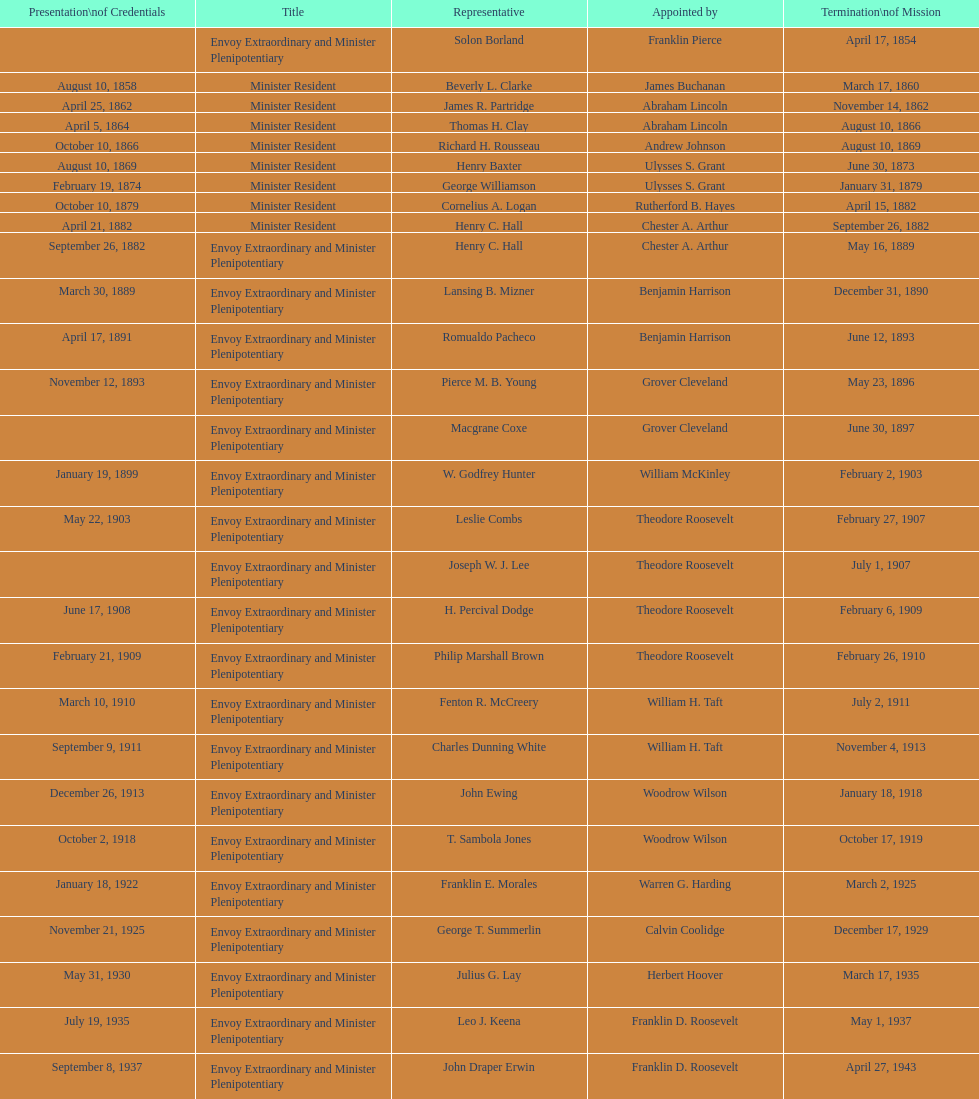Who is the sole ambassador appointed by barack obama to represent the us in honduras? Lisa Kubiske. Help me parse the entirety of this table. {'header': ['Presentation\\nof Credentials', 'Title', 'Representative', 'Appointed by', 'Termination\\nof Mission'], 'rows': [['', 'Envoy Extraordinary and Minister Plenipotentiary', 'Solon Borland', 'Franklin Pierce', 'April 17, 1854'], ['August 10, 1858', 'Minister Resident', 'Beverly L. Clarke', 'James Buchanan', 'March 17, 1860'], ['April 25, 1862', 'Minister Resident', 'James R. Partridge', 'Abraham Lincoln', 'November 14, 1862'], ['April 5, 1864', 'Minister Resident', 'Thomas H. Clay', 'Abraham Lincoln', 'August 10, 1866'], ['October 10, 1866', 'Minister Resident', 'Richard H. Rousseau', 'Andrew Johnson', 'August 10, 1869'], ['August 10, 1869', 'Minister Resident', 'Henry Baxter', 'Ulysses S. Grant', 'June 30, 1873'], ['February 19, 1874', 'Minister Resident', 'George Williamson', 'Ulysses S. Grant', 'January 31, 1879'], ['October 10, 1879', 'Minister Resident', 'Cornelius A. Logan', 'Rutherford B. Hayes', 'April 15, 1882'], ['April 21, 1882', 'Minister Resident', 'Henry C. Hall', 'Chester A. Arthur', 'September 26, 1882'], ['September 26, 1882', 'Envoy Extraordinary and Minister Plenipotentiary', 'Henry C. Hall', 'Chester A. Arthur', 'May 16, 1889'], ['March 30, 1889', 'Envoy Extraordinary and Minister Plenipotentiary', 'Lansing B. Mizner', 'Benjamin Harrison', 'December 31, 1890'], ['April 17, 1891', 'Envoy Extraordinary and Minister Plenipotentiary', 'Romualdo Pacheco', 'Benjamin Harrison', 'June 12, 1893'], ['November 12, 1893', 'Envoy Extraordinary and Minister Plenipotentiary', 'Pierce M. B. Young', 'Grover Cleveland', 'May 23, 1896'], ['', 'Envoy Extraordinary and Minister Plenipotentiary', 'Macgrane Coxe', 'Grover Cleveland', 'June 30, 1897'], ['January 19, 1899', 'Envoy Extraordinary and Minister Plenipotentiary', 'W. Godfrey Hunter', 'William McKinley', 'February 2, 1903'], ['May 22, 1903', 'Envoy Extraordinary and Minister Plenipotentiary', 'Leslie Combs', 'Theodore Roosevelt', 'February 27, 1907'], ['', 'Envoy Extraordinary and Minister Plenipotentiary', 'Joseph W. J. Lee', 'Theodore Roosevelt', 'July 1, 1907'], ['June 17, 1908', 'Envoy Extraordinary and Minister Plenipotentiary', 'H. Percival Dodge', 'Theodore Roosevelt', 'February 6, 1909'], ['February 21, 1909', 'Envoy Extraordinary and Minister Plenipotentiary', 'Philip Marshall Brown', 'Theodore Roosevelt', 'February 26, 1910'], ['March 10, 1910', 'Envoy Extraordinary and Minister Plenipotentiary', 'Fenton R. McCreery', 'William H. Taft', 'July 2, 1911'], ['September 9, 1911', 'Envoy Extraordinary and Minister Plenipotentiary', 'Charles Dunning White', 'William H. Taft', 'November 4, 1913'], ['December 26, 1913', 'Envoy Extraordinary and Minister Plenipotentiary', 'John Ewing', 'Woodrow Wilson', 'January 18, 1918'], ['October 2, 1918', 'Envoy Extraordinary and Minister Plenipotentiary', 'T. Sambola Jones', 'Woodrow Wilson', 'October 17, 1919'], ['January 18, 1922', 'Envoy Extraordinary and Minister Plenipotentiary', 'Franklin E. Morales', 'Warren G. Harding', 'March 2, 1925'], ['November 21, 1925', 'Envoy Extraordinary and Minister Plenipotentiary', 'George T. Summerlin', 'Calvin Coolidge', 'December 17, 1929'], ['May 31, 1930', 'Envoy Extraordinary and Minister Plenipotentiary', 'Julius G. Lay', 'Herbert Hoover', 'March 17, 1935'], ['July 19, 1935', 'Envoy Extraordinary and Minister Plenipotentiary', 'Leo J. Keena', 'Franklin D. Roosevelt', 'May 1, 1937'], ['September 8, 1937', 'Envoy Extraordinary and Minister Plenipotentiary', 'John Draper Erwin', 'Franklin D. Roosevelt', 'April 27, 1943'], ['April 27, 1943', 'Ambassador Extraordinary and Plenipotentiary', 'John Draper Erwin', 'Franklin D. Roosevelt', 'April 16, 1947'], ['June 23, 1947', 'Ambassador Extraordinary and Plenipotentiary', 'Paul C. Daniels', 'Harry S. Truman', 'October 30, 1947'], ['May 15, 1948', 'Ambassador Extraordinary and Plenipotentiary', 'Herbert S. Bursley', 'Harry S. Truman', 'December 12, 1950'], ['March 14, 1951', 'Ambassador Extraordinary and Plenipotentiary', 'John Draper Erwin', 'Harry S. Truman', 'February 28, 1954'], ['March 5, 1954', 'Ambassador Extraordinary and Plenipotentiary', 'Whiting Willauer', 'Dwight D. Eisenhower', 'March 24, 1958'], ['April 30, 1958', 'Ambassador Extraordinary and Plenipotentiary', 'Robert Newbegin', 'Dwight D. Eisenhower', 'August 3, 1960'], ['November 3, 1960', 'Ambassador Extraordinary and Plenipotentiary', 'Charles R. Burrows', 'Dwight D. Eisenhower', 'June 28, 1965'], ['July 12, 1965', 'Ambassador Extraordinary and Plenipotentiary', 'Joseph J. Jova', 'Lyndon B. Johnson', 'June 21, 1969'], ['November 5, 1969', 'Ambassador Extraordinary and Plenipotentiary', 'Hewson A. Ryan', 'Richard Nixon', 'May 30, 1973'], ['June 15, 1973', 'Ambassador Extraordinary and Plenipotentiary', 'Phillip V. Sanchez', 'Richard Nixon', 'July 17, 1976'], ['October 27, 1976', 'Ambassador Extraordinary and Plenipotentiary', 'Ralph E. Becker', 'Gerald Ford', 'August 1, 1977'], ['October 27, 1977', 'Ambassador Extraordinary and Plenipotentiary', 'Mari-Luci Jaramillo', 'Jimmy Carter', 'September 19, 1980'], ['October 10, 1980', 'Ambassador Extraordinary and Plenipotentiary', 'Jack R. Binns', 'Jimmy Carter', 'October 31, 1981'], ['November 11, 1981', 'Ambassador Extraordinary and Plenipotentiary', 'John D. Negroponte', 'Ronald Reagan', 'May 30, 1985'], ['August 22, 1985', 'Ambassador Extraordinary and Plenipotentiary', 'John Arthur Ferch', 'Ronald Reagan', 'July 9, 1986'], ['November 4, 1986', 'Ambassador Extraordinary and Plenipotentiary', 'Everett Ellis Briggs', 'Ronald Reagan', 'June 15, 1989'], ['January 29, 1990', 'Ambassador Extraordinary and Plenipotentiary', 'Cresencio S. Arcos, Jr.', 'George H. W. Bush', 'July 1, 1993'], ['July 21, 1993', 'Ambassador Extraordinary and Plenipotentiary', 'William Thornton Pryce', 'Bill Clinton', 'August 15, 1996'], ['August 29, 1996', 'Ambassador Extraordinary and Plenipotentiary', 'James F. Creagan', 'Bill Clinton', 'July 20, 1999'], ['August 25, 1999', 'Ambassador Extraordinary and Plenipotentiary', 'Frank Almaguer', 'Bill Clinton', 'September 5, 2002'], ['October 8, 2002', 'Ambassador Extraordinary and Plenipotentiary', 'Larry Leon Palmer', 'George W. Bush', 'May 7, 2005'], ['November 8, 2005', 'Ambassador Extraordinary and Plenipotentiary', 'Charles A. Ford', 'George W. Bush', 'ca. April 2008'], ['September 19, 2008', 'Ambassador Extraordinary and Plenipotentiary', 'Hugo Llorens', 'George W. Bush', 'ca. July 2011'], ['July 26, 2011', 'Ambassador Extraordinary and Plenipotentiary', 'Lisa Kubiske', 'Barack Obama', 'Incumbent']]} 